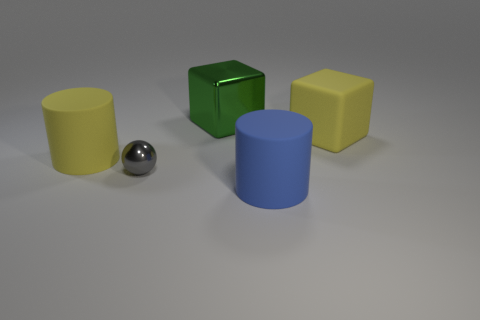Add 2 tiny blue spheres. How many objects exist? 7 Subtract all cylinders. How many objects are left? 3 Add 1 large things. How many large things are left? 5 Add 1 big metal objects. How many big metal objects exist? 2 Subtract 0 red cylinders. How many objects are left? 5 Subtract all green shiny cubes. Subtract all large blue rubber spheres. How many objects are left? 4 